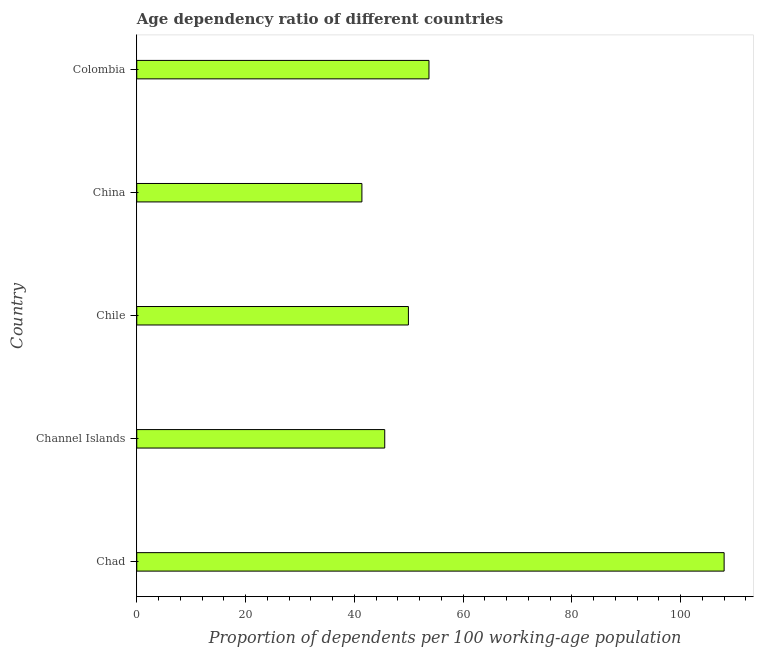What is the title of the graph?
Give a very brief answer. Age dependency ratio of different countries. What is the label or title of the X-axis?
Your answer should be compact. Proportion of dependents per 100 working-age population. What is the label or title of the Y-axis?
Keep it short and to the point. Country. What is the age dependency ratio in Colombia?
Ensure brevity in your answer.  53.73. Across all countries, what is the maximum age dependency ratio?
Offer a very short reply. 108. Across all countries, what is the minimum age dependency ratio?
Provide a short and direct response. 41.4. In which country was the age dependency ratio maximum?
Ensure brevity in your answer.  Chad. What is the sum of the age dependency ratio?
Offer a terse response. 298.67. What is the difference between the age dependency ratio in Chile and Colombia?
Give a very brief answer. -3.78. What is the average age dependency ratio per country?
Give a very brief answer. 59.73. What is the median age dependency ratio?
Provide a short and direct response. 49.95. What is the ratio of the age dependency ratio in Chad to that in Colombia?
Keep it short and to the point. 2.01. Is the age dependency ratio in Channel Islands less than that in China?
Offer a terse response. No. Is the difference between the age dependency ratio in China and Colombia greater than the difference between any two countries?
Provide a succinct answer. No. What is the difference between the highest and the second highest age dependency ratio?
Your answer should be very brief. 54.27. Is the sum of the age dependency ratio in Chile and China greater than the maximum age dependency ratio across all countries?
Your answer should be compact. No. What is the difference between the highest and the lowest age dependency ratio?
Give a very brief answer. 66.6. What is the difference between two consecutive major ticks on the X-axis?
Provide a succinct answer. 20. Are the values on the major ticks of X-axis written in scientific E-notation?
Your answer should be very brief. No. What is the Proportion of dependents per 100 working-age population in Chad?
Give a very brief answer. 108. What is the Proportion of dependents per 100 working-age population of Channel Islands?
Offer a terse response. 45.59. What is the Proportion of dependents per 100 working-age population of Chile?
Provide a succinct answer. 49.95. What is the Proportion of dependents per 100 working-age population in China?
Ensure brevity in your answer.  41.4. What is the Proportion of dependents per 100 working-age population of Colombia?
Keep it short and to the point. 53.73. What is the difference between the Proportion of dependents per 100 working-age population in Chad and Channel Islands?
Offer a very short reply. 62.41. What is the difference between the Proportion of dependents per 100 working-age population in Chad and Chile?
Provide a short and direct response. 58.05. What is the difference between the Proportion of dependents per 100 working-age population in Chad and China?
Your answer should be compact. 66.6. What is the difference between the Proportion of dependents per 100 working-age population in Chad and Colombia?
Your response must be concise. 54.27. What is the difference between the Proportion of dependents per 100 working-age population in Channel Islands and Chile?
Give a very brief answer. -4.35. What is the difference between the Proportion of dependents per 100 working-age population in Channel Islands and China?
Provide a succinct answer. 4.2. What is the difference between the Proportion of dependents per 100 working-age population in Channel Islands and Colombia?
Offer a very short reply. -8.13. What is the difference between the Proportion of dependents per 100 working-age population in Chile and China?
Offer a very short reply. 8.55. What is the difference between the Proportion of dependents per 100 working-age population in Chile and Colombia?
Your answer should be compact. -3.78. What is the difference between the Proportion of dependents per 100 working-age population in China and Colombia?
Provide a short and direct response. -12.33. What is the ratio of the Proportion of dependents per 100 working-age population in Chad to that in Channel Islands?
Provide a succinct answer. 2.37. What is the ratio of the Proportion of dependents per 100 working-age population in Chad to that in Chile?
Make the answer very short. 2.16. What is the ratio of the Proportion of dependents per 100 working-age population in Chad to that in China?
Keep it short and to the point. 2.61. What is the ratio of the Proportion of dependents per 100 working-age population in Chad to that in Colombia?
Offer a terse response. 2.01. What is the ratio of the Proportion of dependents per 100 working-age population in Channel Islands to that in China?
Provide a succinct answer. 1.1. What is the ratio of the Proportion of dependents per 100 working-age population in Channel Islands to that in Colombia?
Your answer should be compact. 0.85. What is the ratio of the Proportion of dependents per 100 working-age population in Chile to that in China?
Your answer should be compact. 1.21. What is the ratio of the Proportion of dependents per 100 working-age population in Chile to that in Colombia?
Provide a short and direct response. 0.93. What is the ratio of the Proportion of dependents per 100 working-age population in China to that in Colombia?
Provide a short and direct response. 0.77. 